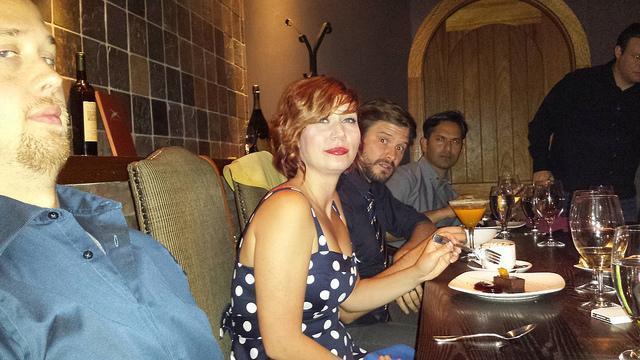How many women are in the picture?
Give a very brief answer. 1. How many wine glasses are in the picture?
Give a very brief answer. 2. How many chairs are in the photo?
Give a very brief answer. 2. How many people can be seen?
Give a very brief answer. 5. 